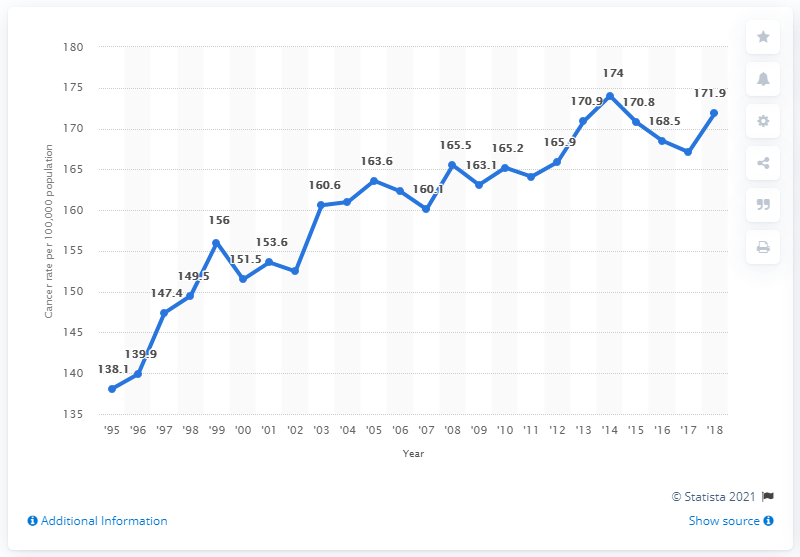Specify some key components in this picture. In 2018, there were 171.9 females diagnosed with breast cancer in England. 